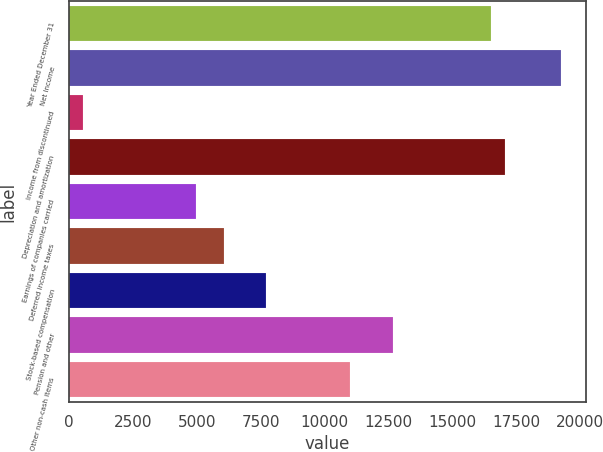Convert chart to OTSL. <chart><loc_0><loc_0><loc_500><loc_500><bar_chart><fcel>Year Ended December 31<fcel>Net Income<fcel>Income from discontinued<fcel>Depreciation and amortization<fcel>Earnings of companies carried<fcel>Deferred income taxes<fcel>Stock-based compensation<fcel>Pension and other<fcel>Other non-cash items<nl><fcel>16523<fcel>19276.5<fcel>552.7<fcel>17073.7<fcel>4958.3<fcel>6059.7<fcel>7711.8<fcel>12668.1<fcel>11016<nl></chart> 